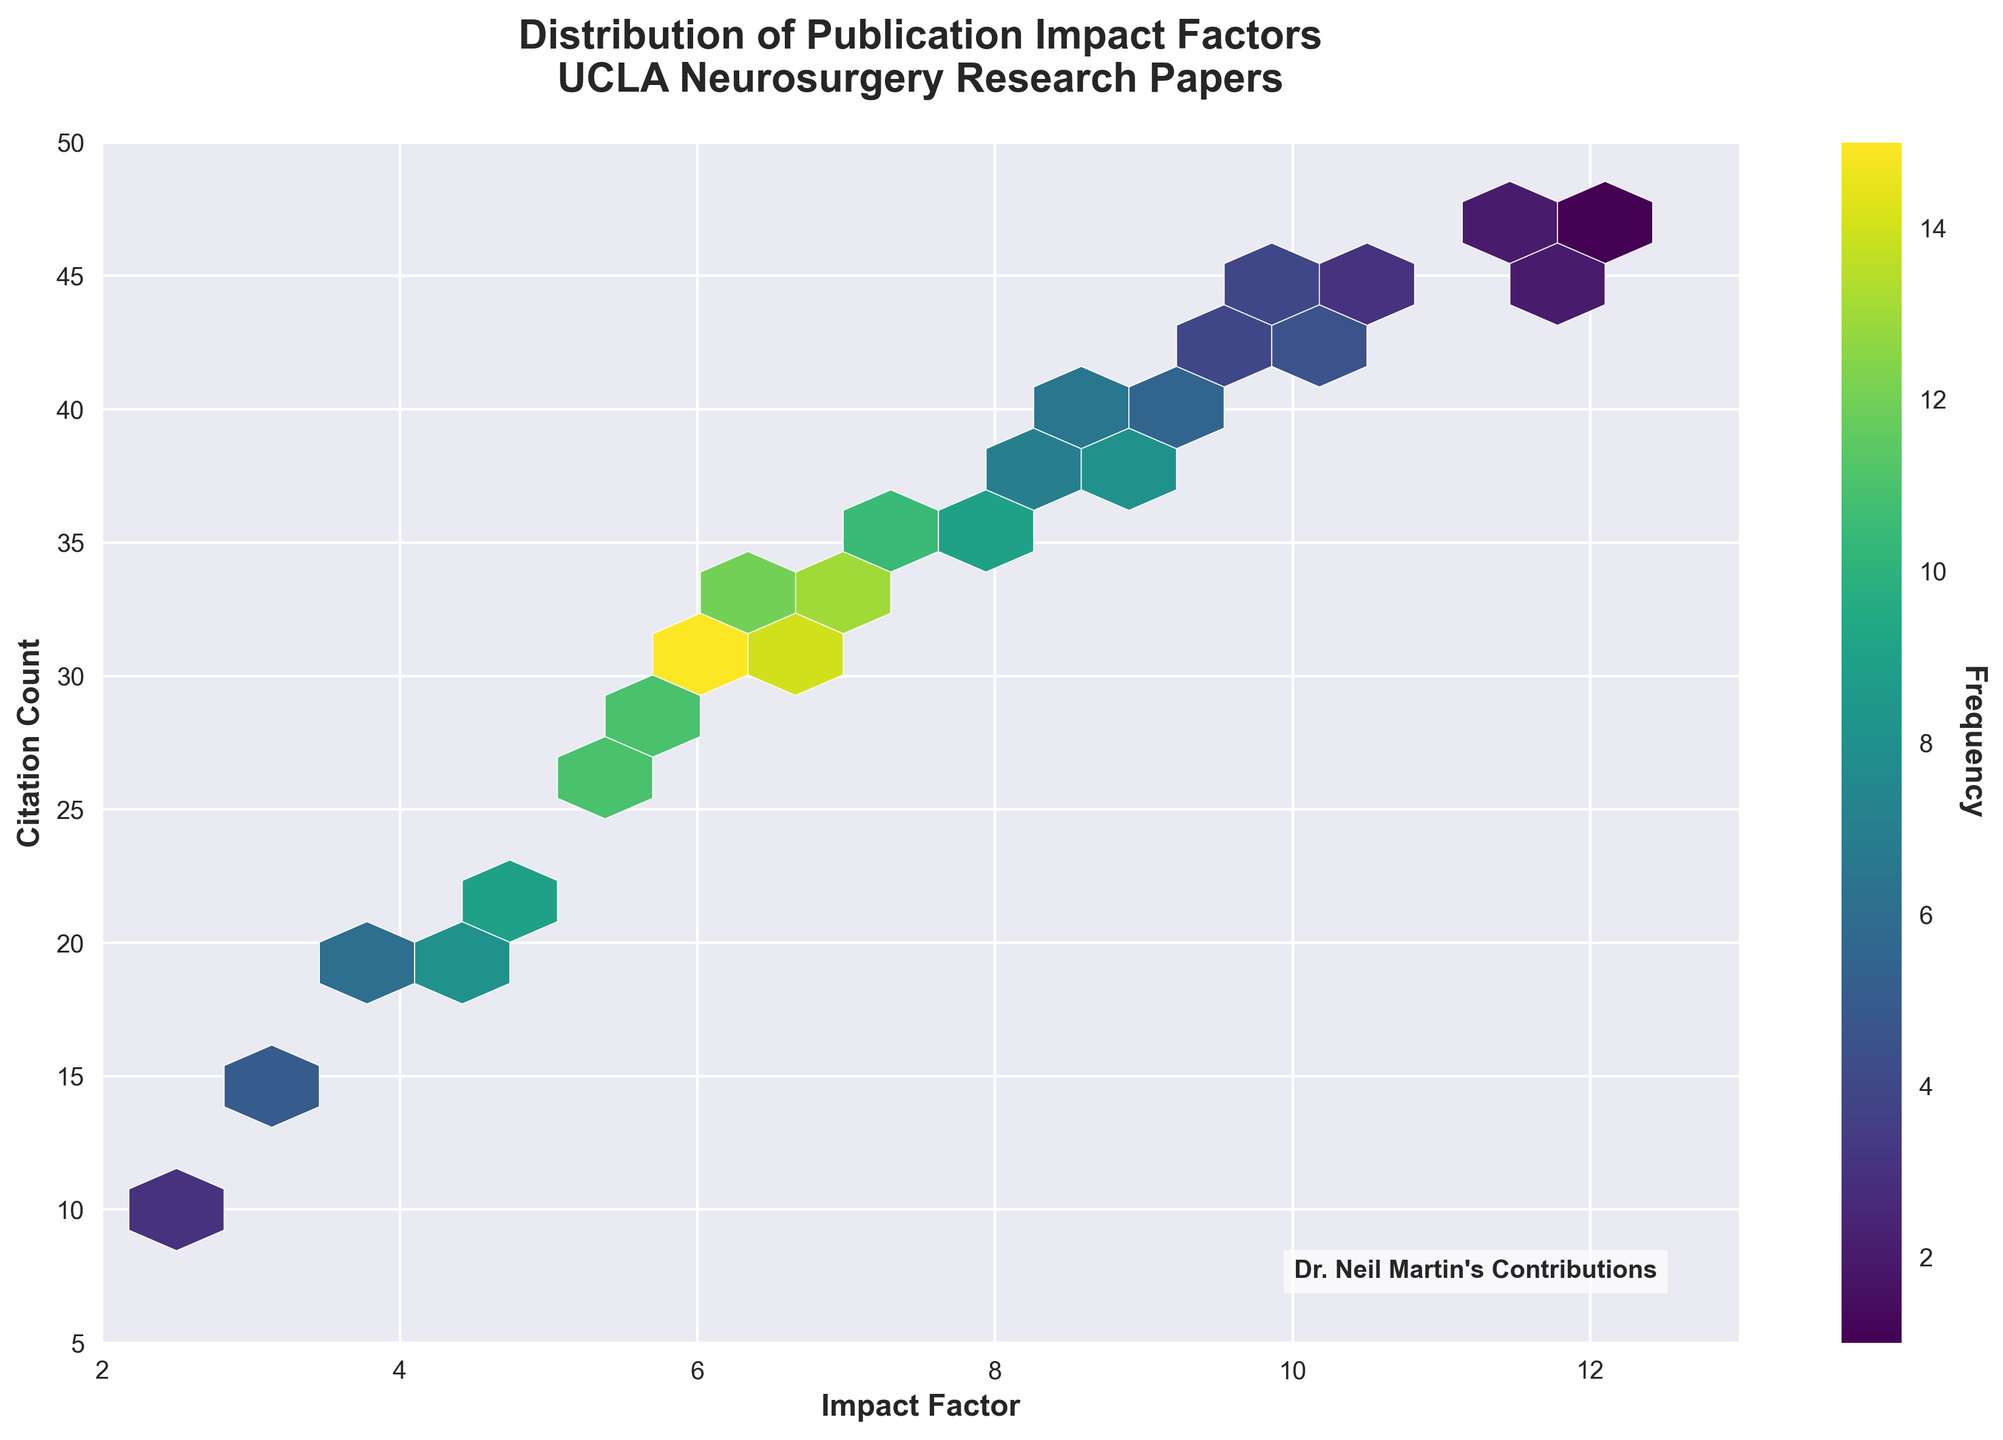What is the title of the plot? The title is located at the top of the figure. It reads: "Distribution of Publication Impact Factors, UCLA Neurosurgery Research Papers."
Answer: Distribution of Publication Impact Factors, UCLA Neurosurgery Research Papers What colors are used in the hexbin plot? The hexbin plot utilizes a color gradient from light to dark shades of viridis color palette, where lighter shades indicate lower frequencies and darker shades indicate higher frequencies.
Answer: Viridis color shades What does the color bar represent in the plot? The color bar is found on the right side of the plot and it represents the frequency of data points within each hexbin cell.
Answer: Frequency What are the x-axis and y-axis labels? The x-axis and y-axis labels are located below and to the left of the plot respectively. The x-axis label is "Impact Factor" and the y-axis label is "Citation Count."
Answer: Impact Factor and Citation Count Which part of the plot mentions Dr. Neil Martin’s contributions? A textbox located in the bottom-right corner of the plot mentions "Dr. Neil Martin's Contributions."
Answer: Bottom-right corner How many frequency levels are indicated in the color bar? You can count the distinct color levels in the color bar; it shows ten different frequency levels.
Answer: Ten levels Which area appears to have the highest concentration of publication impact factors and citations? The highest concentration areas are identified by the darkest hexbin cells, located roughly around 7.3 (Impact Factor) and 34 (Citation Count).
Answer: Around 7.3 Impact Factor and 34 Citation Count What is the range of citation counts displayed on the y-axis? The y-axis starts at 5 and extends to 50, marking the range of citation counts displayed in the plot.
Answer: 5 to 50 How does the frequency of publications change as the impact factor increases from 3 to 8? Observing the color gradient from light to dark in the range of 3 to 8 impact factors, the frequency increases initially and reaches a peak around impact factors 5.6 to 7.5, then decreases again.
Answer: Increases then decreases What is the impact factor with the maximum citation count concurrently having a high frequency? The impact factor that shows high citation counts and also a relatively high frequency is around 7.5.
Answer: 7.5 